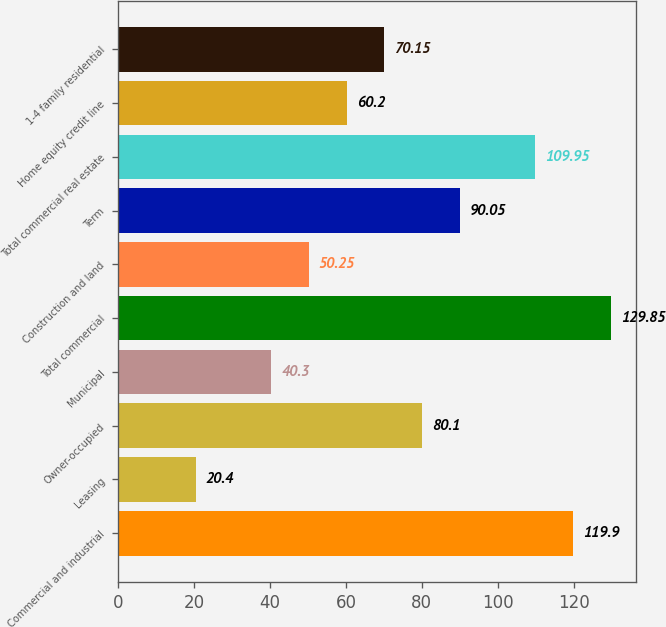<chart> <loc_0><loc_0><loc_500><loc_500><bar_chart><fcel>Commercial and industrial<fcel>Leasing<fcel>Owner-occupied<fcel>Municipal<fcel>Total commercial<fcel>Construction and land<fcel>Term<fcel>Total commercial real estate<fcel>Home equity credit line<fcel>1-4 family residential<nl><fcel>119.9<fcel>20.4<fcel>80.1<fcel>40.3<fcel>129.85<fcel>50.25<fcel>90.05<fcel>109.95<fcel>60.2<fcel>70.15<nl></chart> 